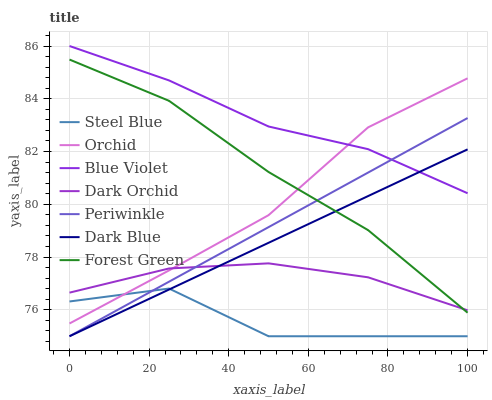Does Steel Blue have the minimum area under the curve?
Answer yes or no. Yes. Does Blue Violet have the maximum area under the curve?
Answer yes or no. Yes. Does Dark Orchid have the minimum area under the curve?
Answer yes or no. No. Does Dark Orchid have the maximum area under the curve?
Answer yes or no. No. Is Dark Blue the smoothest?
Answer yes or no. Yes. Is Steel Blue the roughest?
Answer yes or no. Yes. Is Dark Orchid the smoothest?
Answer yes or no. No. Is Dark Orchid the roughest?
Answer yes or no. No. Does Steel Blue have the lowest value?
Answer yes or no. Yes. Does Dark Orchid have the lowest value?
Answer yes or no. No. Does Blue Violet have the highest value?
Answer yes or no. Yes. Does Dark Orchid have the highest value?
Answer yes or no. No. Is Dark Orchid less than Blue Violet?
Answer yes or no. Yes. Is Orchid greater than Dark Blue?
Answer yes or no. Yes. Does Orchid intersect Dark Orchid?
Answer yes or no. Yes. Is Orchid less than Dark Orchid?
Answer yes or no. No. Is Orchid greater than Dark Orchid?
Answer yes or no. No. Does Dark Orchid intersect Blue Violet?
Answer yes or no. No. 